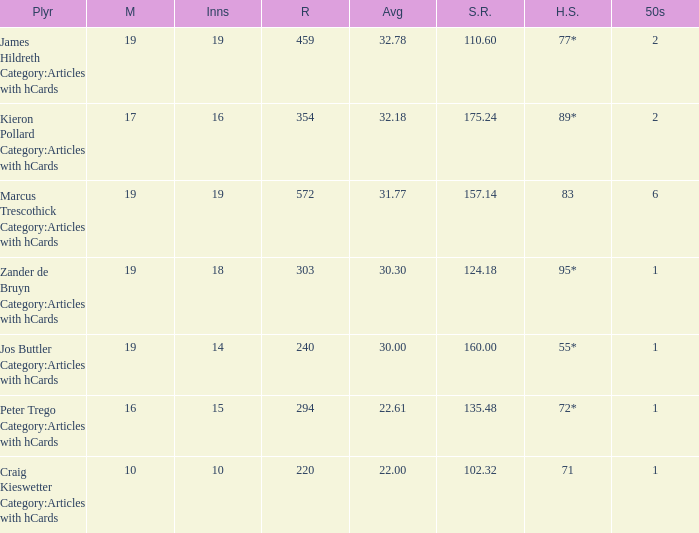How many innings for the player with an average of 22.61? 15.0. 